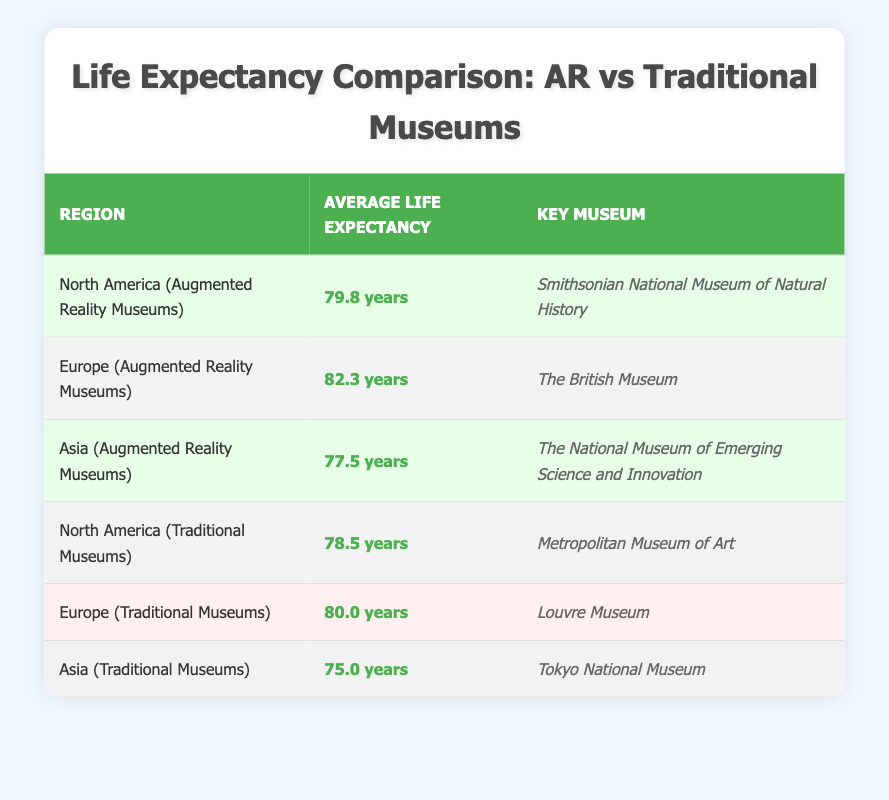What is the average life expectancy in Europe among regions with augmented reality museums? The table indicates that the average life expectancy in Europe with augmented reality museums is stated directly in the respective row: 82.3 years.
Answer: 82.3 years Which region has the highest life expectancy in the table? By comparing the average life expectancy values across all regions listed in the table, Europe (Augmented Reality Museums) at 82.3 years has the highest value.
Answer: Europe (Augmented Reality Museums) What is the difference in average life expectancy between North America with augmented reality museums and North America with traditional museums? To find the difference, subtract the life expectancy of North America with traditional museums (78.5 years) from that of North America with augmented reality museums (79.8 years). The calculation is 79.8 - 78.5 = 1.3 years.
Answer: 1.3 years Is the average life expectancy higher in European regions with augmented reality museums compared to Asian regions with traditional museums? The average life expectancy in Europe with augmented reality museums is 82.3 years, whereas Asia with traditional museums has an average of 75.0 years. Since 82.3 is greater than 75.0, the statement is true.
Answer: Yes What is the average life expectancy across all augmented reality museum regions? To find this, sum the average life expectancies of the augmented reality regions: (79.8 + 82.3 + 77.5) = 239.6 years. Then, divide this total by the number of regions (3): 239.6 / 3 = 79.8667, which rounds to approximately 79.87.
Answer: 79.87 years Is the key museum for Europe with augmented reality the same as the one for Europe with traditional museums? The key museum for Europe with augmented reality is "The British Museum," while for traditional museums, it is "Louvre Museum." Since these names differ, the answer is no.
Answer: No Which region's average life expectancy is closest to 80 years, and is it from an augmented reality or traditional museum? The average life expectancy for Europe with traditional museums is 80.0 years, which is exactly 80 years. Checking the table, it belongs to the traditional museum category.
Answer: Europe (Traditional Museums) Which region's life expectancy would you expect to be lower, Asia with augmented reality museums or Asia with traditional museums? By examining the values in the table, Asia with augmented reality museums has an average life expectancy of 77.5 years, while Asia with traditional museums has 75.0 years. 77.5 is greater, indicating that Asia with augmented reality has a higher life expectancy.
Answer: Asia with traditional museums 